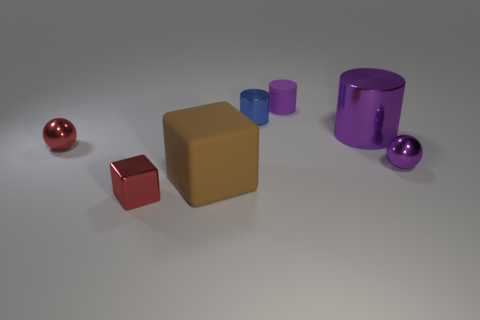Are there any other things that have the same color as the large cylinder?
Provide a short and direct response. Yes. How many objects are either small matte things or big purple metal objects?
Keep it short and to the point. 2. Does the purple metallic object that is in front of the red metallic sphere have the same size as the rubber block?
Your response must be concise. No. How many other objects are the same size as the metal block?
Make the answer very short. 4. Are there any large gray blocks?
Your response must be concise. No. What is the size of the red shiny sphere that is in front of the metallic cylinder left of the purple rubber thing?
Your answer should be compact. Small. Do the small ball that is in front of the red ball and the metallic cylinder in front of the blue thing have the same color?
Provide a succinct answer. Yes. There is a tiny object that is both right of the blue cylinder and on the left side of the purple ball; what is its color?
Your response must be concise. Purple. How many other objects are the same shape as the small rubber thing?
Your answer should be very brief. 2. There is another sphere that is the same size as the purple sphere; what color is it?
Your answer should be compact. Red. 